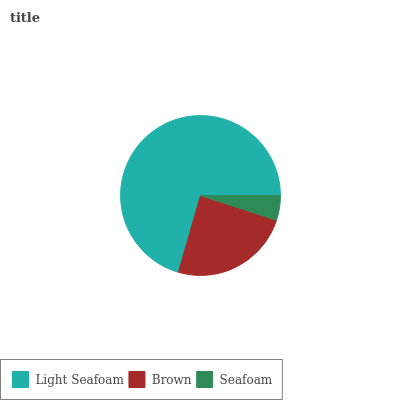Is Seafoam the minimum?
Answer yes or no. Yes. Is Light Seafoam the maximum?
Answer yes or no. Yes. Is Brown the minimum?
Answer yes or no. No. Is Brown the maximum?
Answer yes or no. No. Is Light Seafoam greater than Brown?
Answer yes or no. Yes. Is Brown less than Light Seafoam?
Answer yes or no. Yes. Is Brown greater than Light Seafoam?
Answer yes or no. No. Is Light Seafoam less than Brown?
Answer yes or no. No. Is Brown the high median?
Answer yes or no. Yes. Is Brown the low median?
Answer yes or no. Yes. Is Light Seafoam the high median?
Answer yes or no. No. Is Light Seafoam the low median?
Answer yes or no. No. 